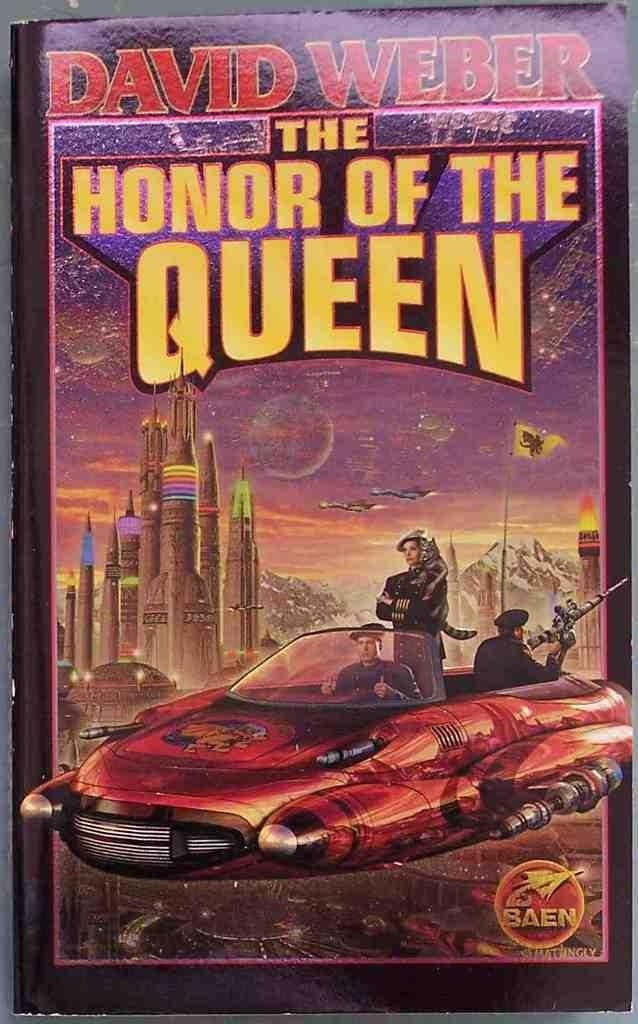What is present in the image related to reading material? There is a book in the image. What type of content can be found in the book? The book contains images and text. What type of card can be seen being used to act out a scene in the image? There is no card or act being performed in the image; it only features a book with images and text. What type of ear can be seen attached to the book in the image? There is no ear present in the image; it only features a book with images and text. 